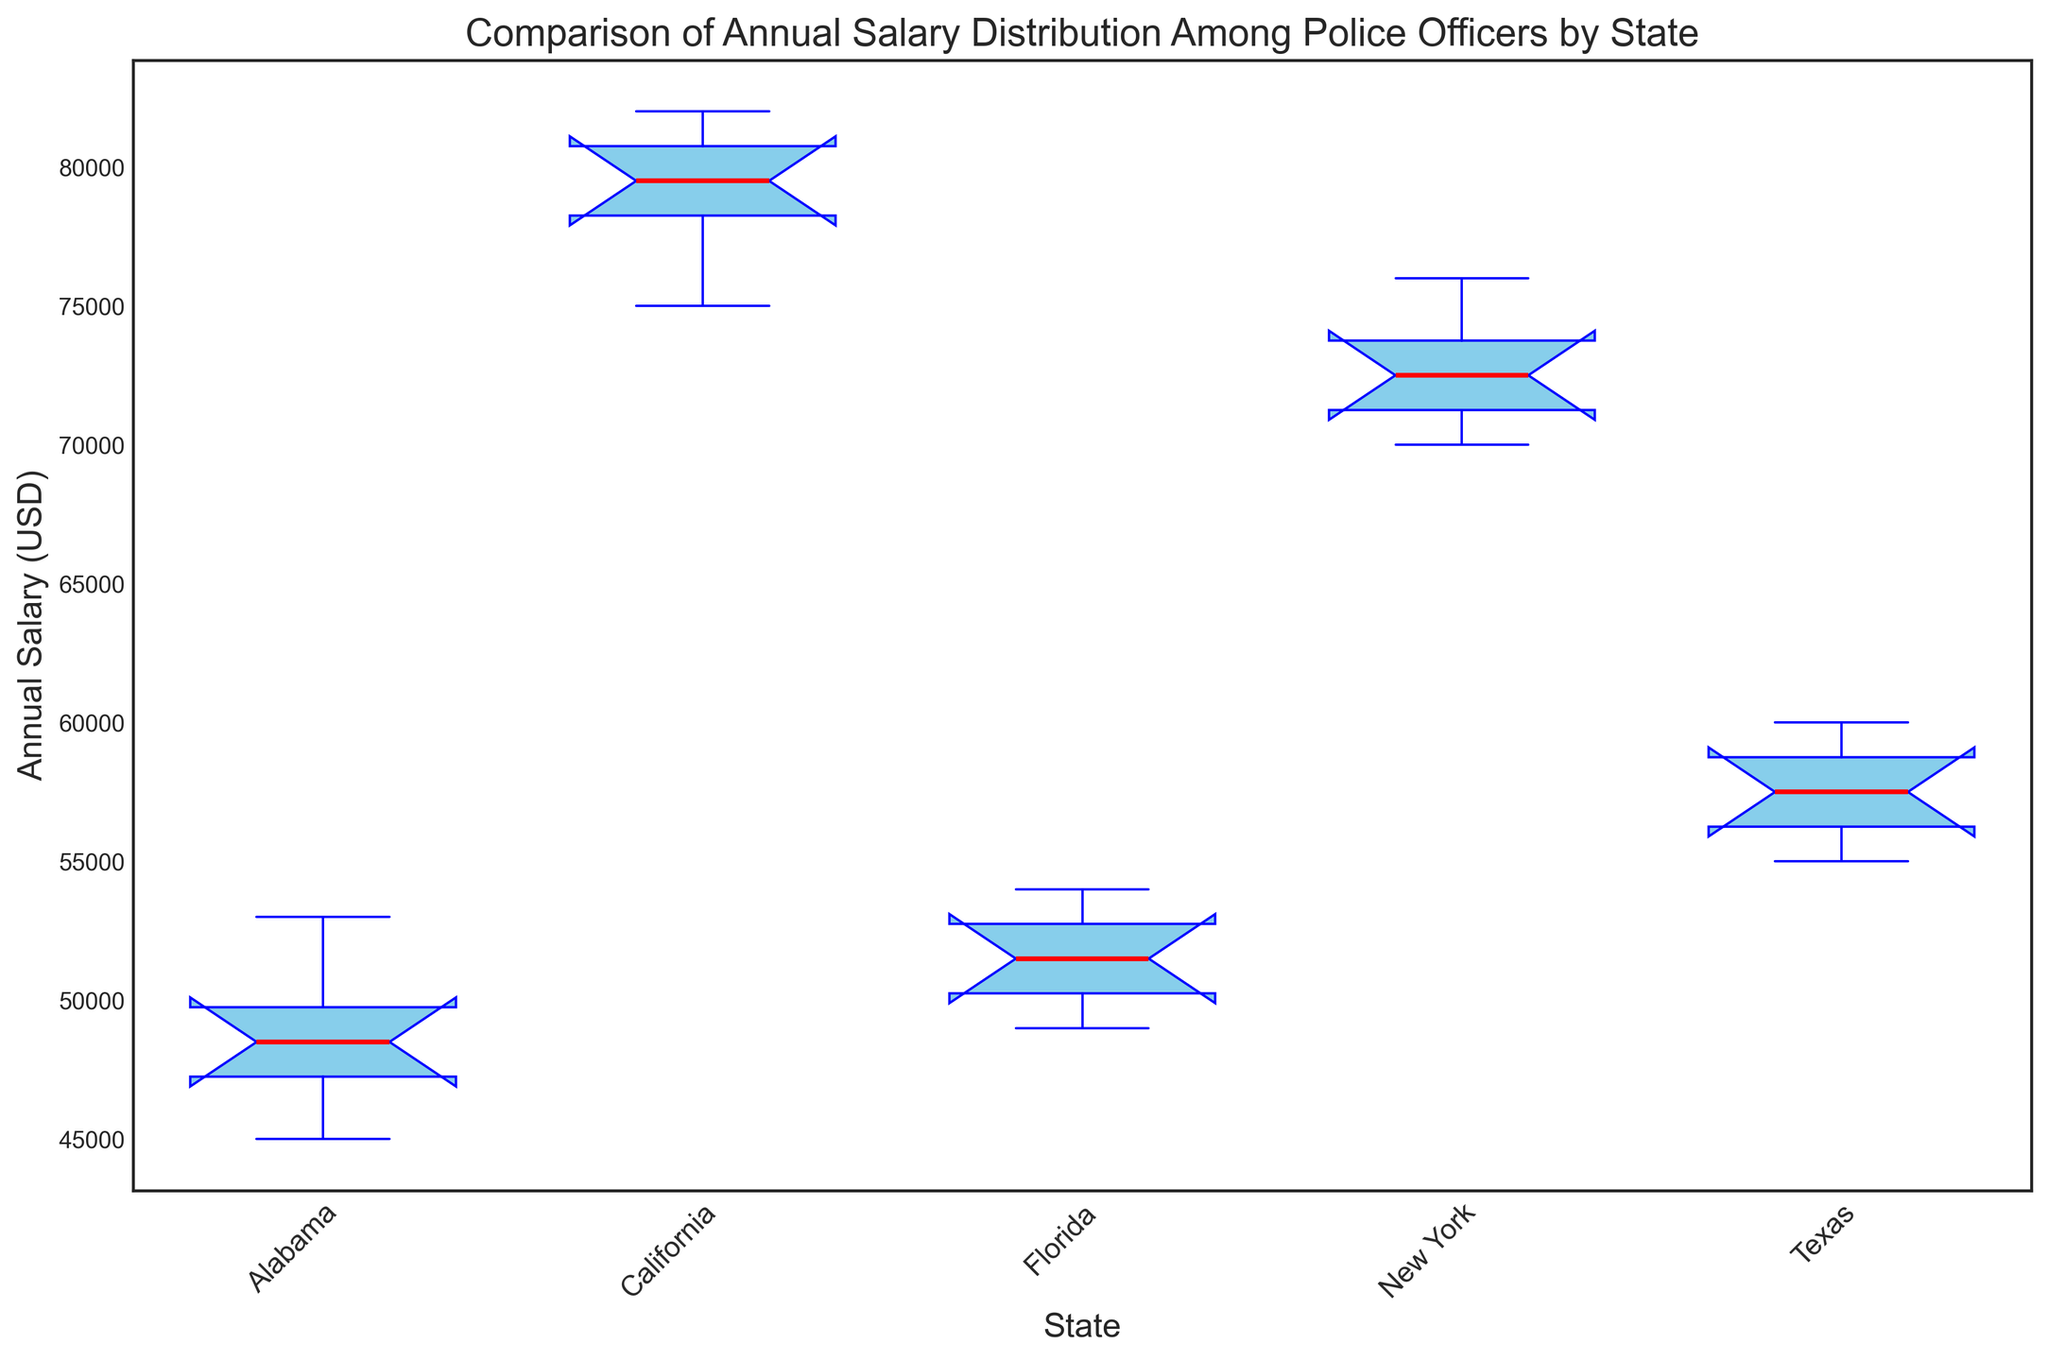Which state has the highest median annual salary for police officers? Look at the position of the median line (red line) in each box plot. The one that is the highest will indicate the state with the highest median annual salary.
Answer: California What is the approximate range of annual salaries for police officers in Texas? Identify the top and bottom whiskers for Texas. The range is calculated by subtracting the minimum salary value from the maximum salary value.
Answer: 55000 to 60000 Between Alabama and Florida, which state has a higher median annual salary for police officers? Compare the red lines (medians) of Alabama and Florida. The box plot with the higher red line represents the state with the higher median annual salary.
Answer: Florida How does the variability in annual salaries compare between California and New York? Compare the height of the boxes and the length of the whiskers for California and New York. Greater height or longer whiskers denote more variability.
Answer: California has more variability Which state has the smallest interquartile range (IQR) of annual salaries for police officers? The IQR is represented by the height of the box (from the bottom of the box to the top). Look for the state with the smallest box height.
Answer: Texas Compare the upper whiskers of Florida and New York. Which state has a higher maximum annual salary for police officers? The upper whisker indicates the maximum non-outlier salary. The whisker that extends higher indicates the higher maximum salary.
Answer: New York Among the states listed, which one shows the lowest annual salary value? Look at the bottom whiskers or the lower fences for each state. The lowest point indicates the lowest annual salary.
Answer: Alabama Is the median annual salary for police officers in Alabama greater than the 25th percentile (first quartile) salary in California? Compare Alabama's median (red line) with the bottom of the box (25th percentile) of California. Ensure Alabama's red line is higher than California's 25th percentile line.
Answer: No What can you say about the skewness of the annual salary distributions in New York versus Texas? Observe the length of the whiskers and the position of the median line within the box. Longer whiskers on one side and a median line closer to the quartiles indicate skewness.
Answer: New York is relatively symmetrical; Texas is slightly skewed right 